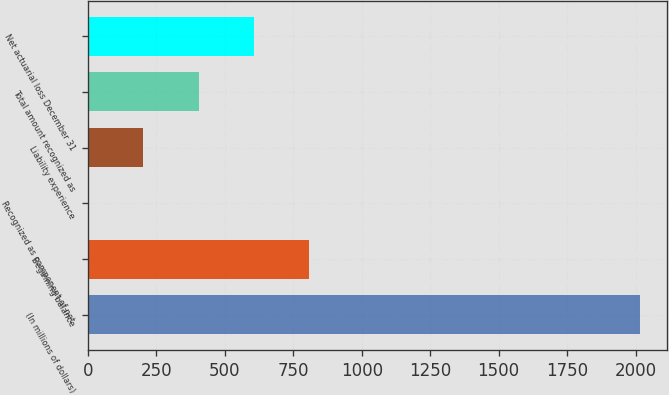Convert chart. <chart><loc_0><loc_0><loc_500><loc_500><bar_chart><fcel>(In millions of dollars)<fcel>Beginning balance<fcel>Recognized as component of net<fcel>Liability experience<fcel>Total amount recognized as<fcel>Net actuarial loss December 31<nl><fcel>2015<fcel>806.6<fcel>1<fcel>202.4<fcel>403.8<fcel>605.2<nl></chart> 